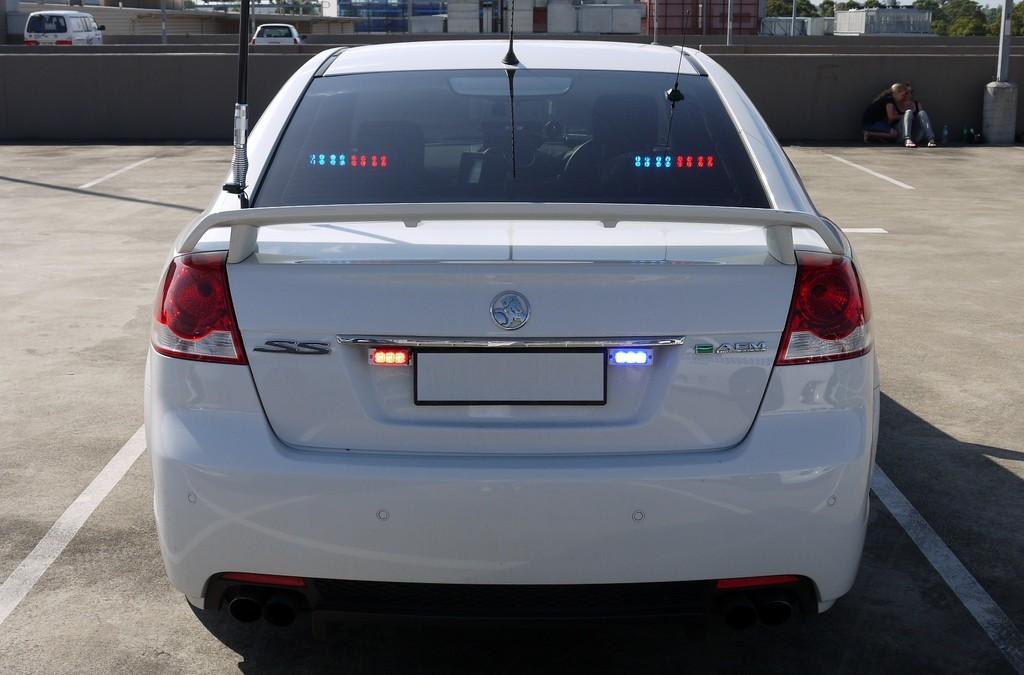What is the main subject of the image? There is a vehicle in the image. What else can be seen in the image besides the vehicle? There are people on the ground in the image. What can be seen in the background of the image? There is a wall, vehicles, buildings, trees, poles, and some objects in the background of the image. Can you describe the weather in the image? There is no information about the weather in the image, as it does not depict any weather-related elements. 